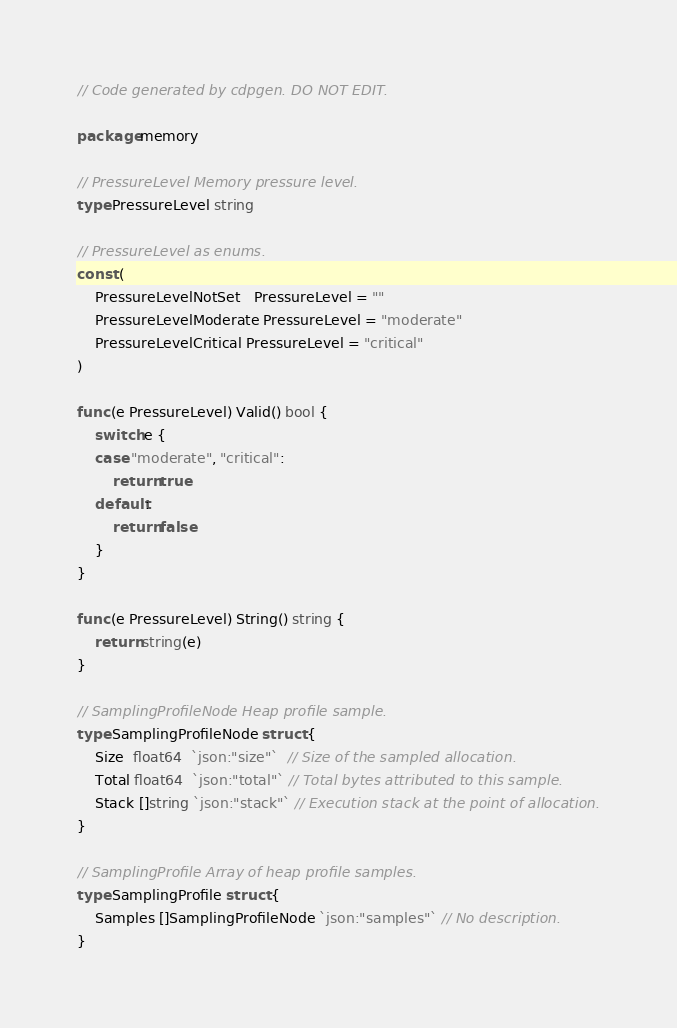Convert code to text. <code><loc_0><loc_0><loc_500><loc_500><_Go_>// Code generated by cdpgen. DO NOT EDIT.

package memory

// PressureLevel Memory pressure level.
type PressureLevel string

// PressureLevel as enums.
const (
	PressureLevelNotSet   PressureLevel = ""
	PressureLevelModerate PressureLevel = "moderate"
	PressureLevelCritical PressureLevel = "critical"
)

func (e PressureLevel) Valid() bool {
	switch e {
	case "moderate", "critical":
		return true
	default:
		return false
	}
}

func (e PressureLevel) String() string {
	return string(e)
}

// SamplingProfileNode Heap profile sample.
type SamplingProfileNode struct {
	Size  float64  `json:"size"`  // Size of the sampled allocation.
	Total float64  `json:"total"` // Total bytes attributed to this sample.
	Stack []string `json:"stack"` // Execution stack at the point of allocation.
}

// SamplingProfile Array of heap profile samples.
type SamplingProfile struct {
	Samples []SamplingProfileNode `json:"samples"` // No description.
}
</code> 